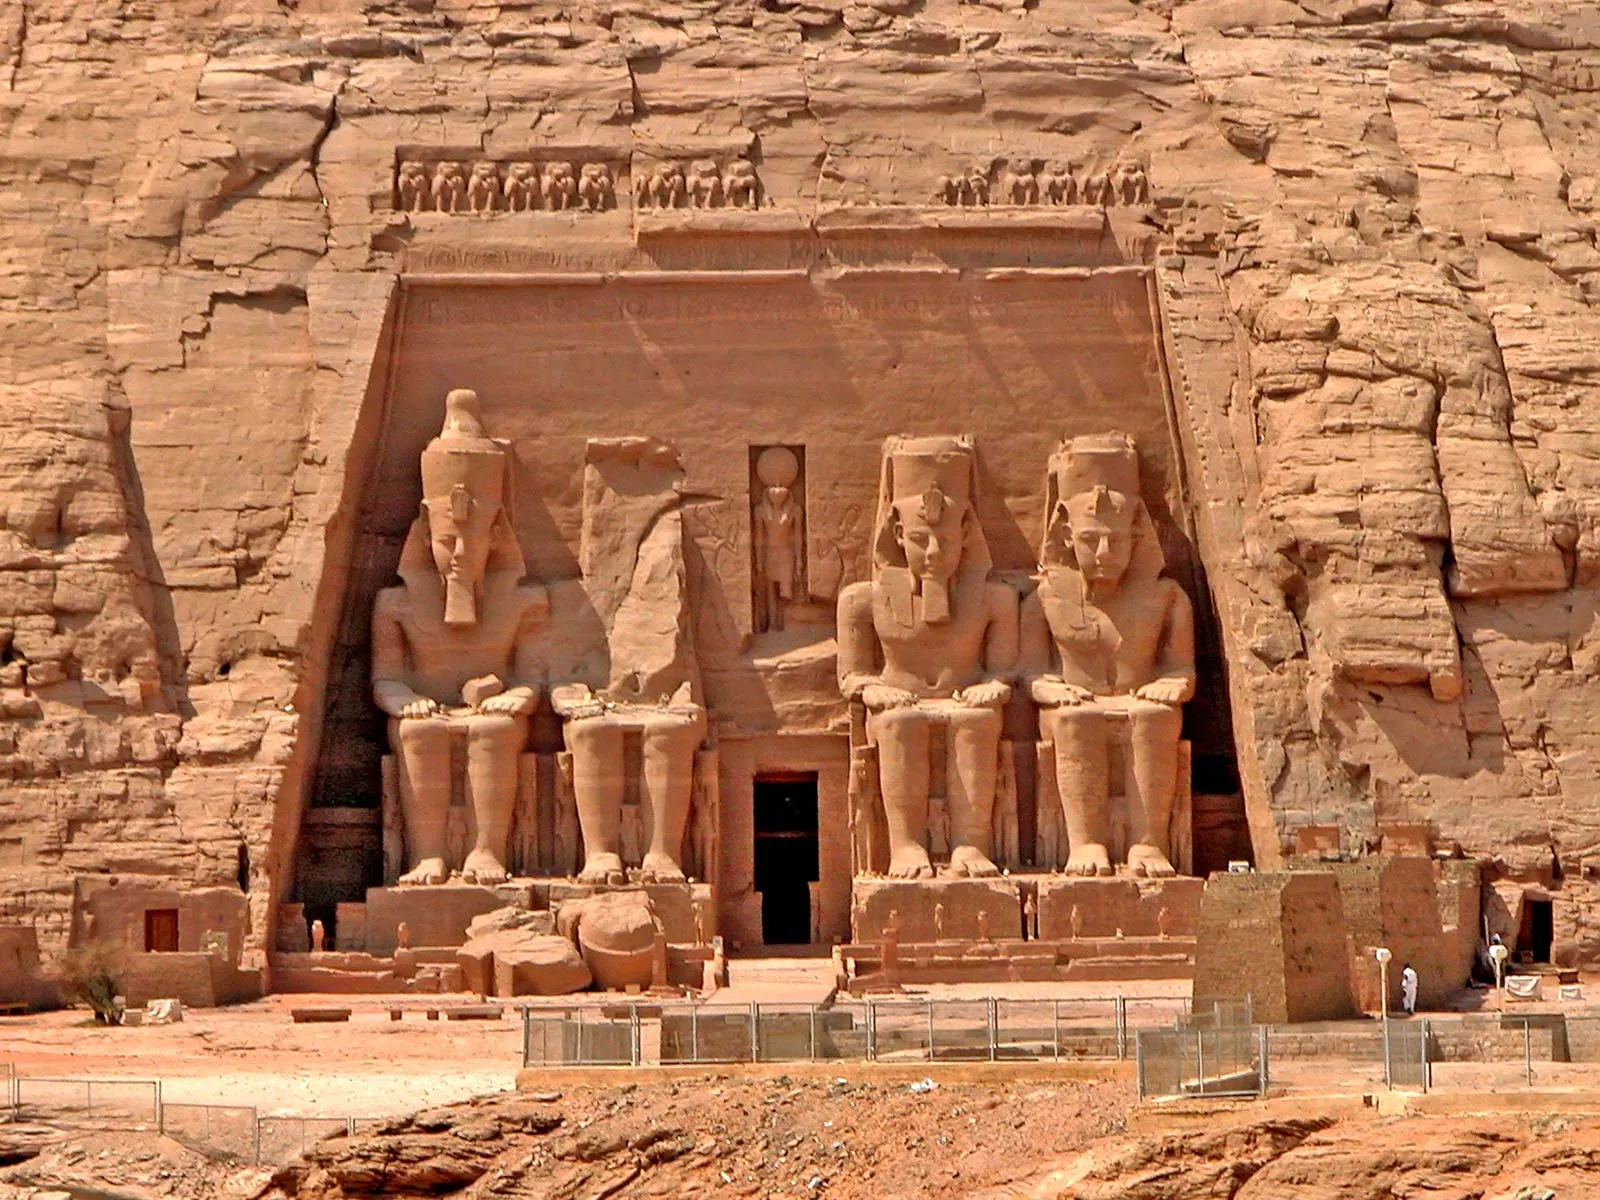What is the historical significance of the Abu Simbel temple? Abu Simbel is historically significant primarily because it commemorates the victory of Ramesses II at the Battle of Kadesh. It also serves as a lasting monument to the king and his queen Nefertari, intended to showcase their power and divine nature to neighboring regions. Additionally, the temple's relocation in 1968 to save it from submersion in Lake Nasser following the Aswan High Dam construction is a testament to global efforts in heritage preservation, symbolizing the universal value and enduring legacy of ancient Egyptian culture. 